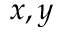Convert formula to latex. <formula><loc_0><loc_0><loc_500><loc_500>x , y</formula> 